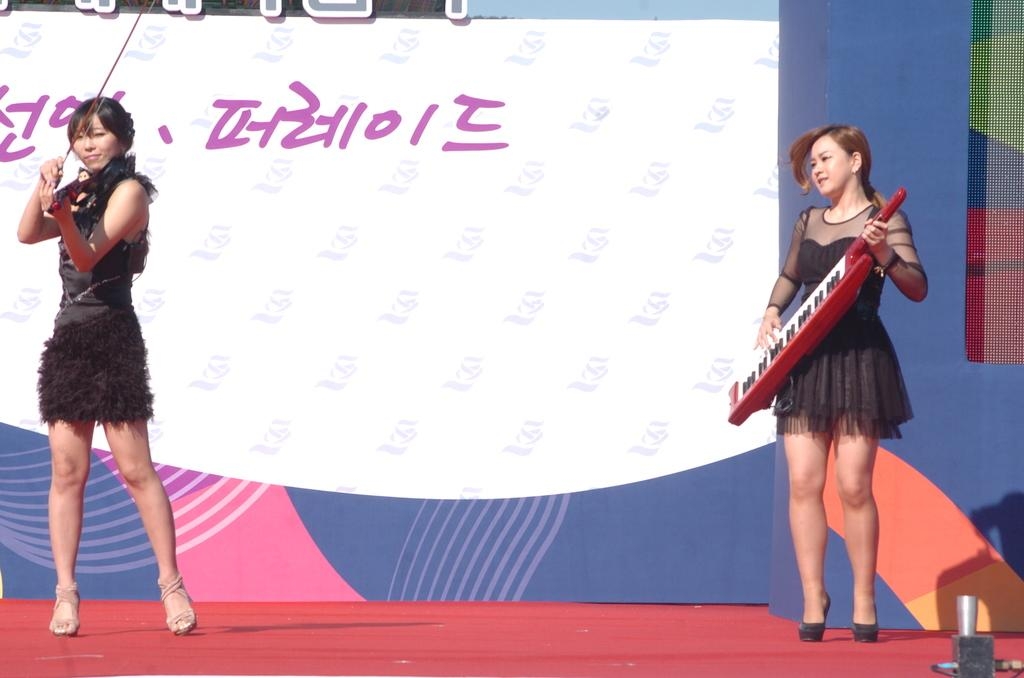How many women are present in the image? There are two women in the image. What are the women doing in the image? The women are playing music in the image. Where are the women standing in the image? The women are standing on a dais in the image. What is visible behind the women in the image? There is a banner behind the women in the image. What are the women wearing in the image? Both women are wearing black dresses in the image. What type of coil is being used by the women to create music in the image? There is no coil present in the image; the women are playing music using instruments, not a coil. Can you recite the verse written on the banner in the image? There is no verse visible on the banner in the image; only the banner itself is mentioned. 